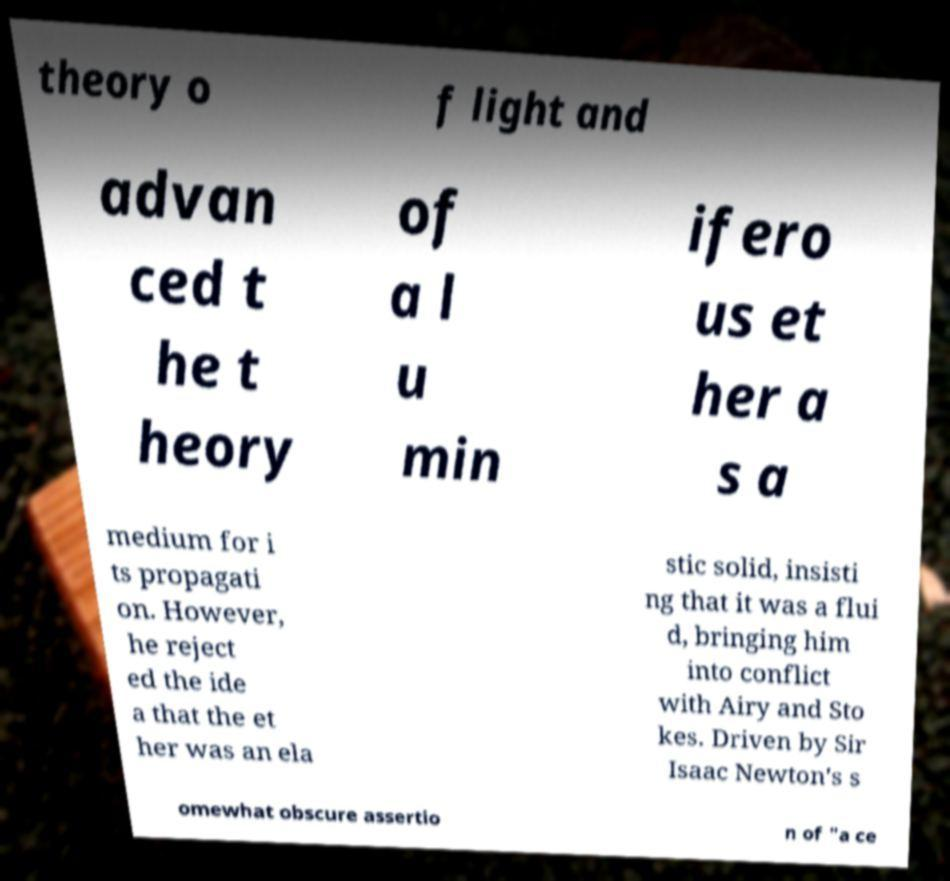Can you read and provide the text displayed in the image?This photo seems to have some interesting text. Can you extract and type it out for me? theory o f light and advan ced t he t heory of a l u min ifero us et her a s a medium for i ts propagati on. However, he reject ed the ide a that the et her was an ela stic solid, insisti ng that it was a flui d, bringing him into conflict with Airy and Sto kes. Driven by Sir Isaac Newton's s omewhat obscure assertio n of "a ce 